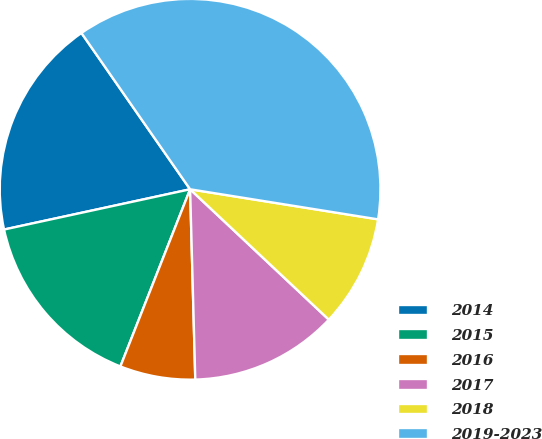Convert chart. <chart><loc_0><loc_0><loc_500><loc_500><pie_chart><fcel>2014<fcel>2015<fcel>2016<fcel>2017<fcel>2018<fcel>2019-2023<nl><fcel>18.72%<fcel>15.64%<fcel>6.4%<fcel>12.56%<fcel>9.48%<fcel>37.19%<nl></chart> 